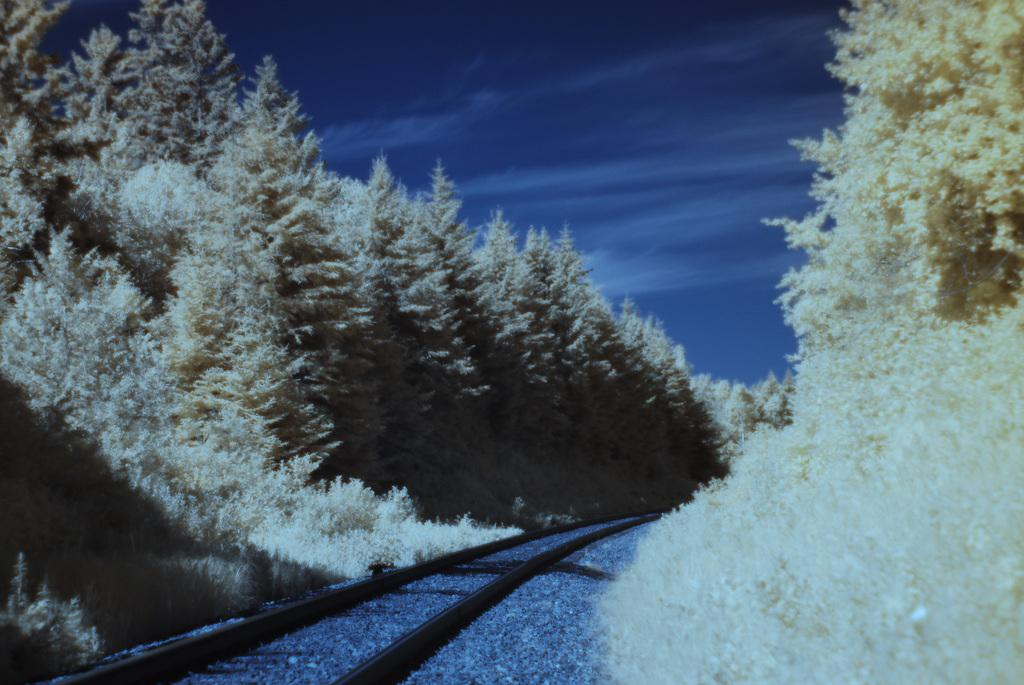What is on the ground in the image? There is a railway track on the ground in the image. What type of vegetation can be seen in the image? There are trees in the image. What color scheme is used in the image? The image is in black and white color. How many wings can be seen on the trees in the image? There are no wings present on the trees in the image, as trees do not have wings. 